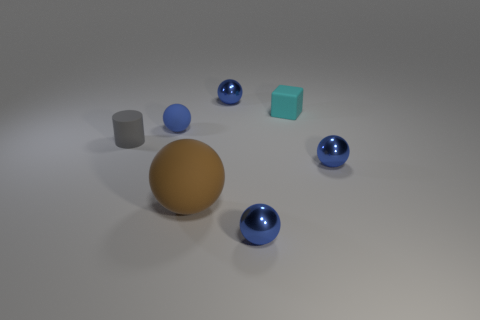Subtract all cyan cylinders. How many blue balls are left? 4 Subtract all brown spheres. How many spheres are left? 4 Subtract all tiny blue matte spheres. How many spheres are left? 4 Subtract all red balls. Subtract all green blocks. How many balls are left? 5 Add 1 blue matte balls. How many objects exist? 8 Subtract all cylinders. How many objects are left? 6 Add 5 tiny metallic balls. How many tiny metallic balls exist? 8 Subtract 1 gray cylinders. How many objects are left? 6 Subtract all small blue metal objects. Subtract all brown matte things. How many objects are left? 3 Add 4 rubber cubes. How many rubber cubes are left? 5 